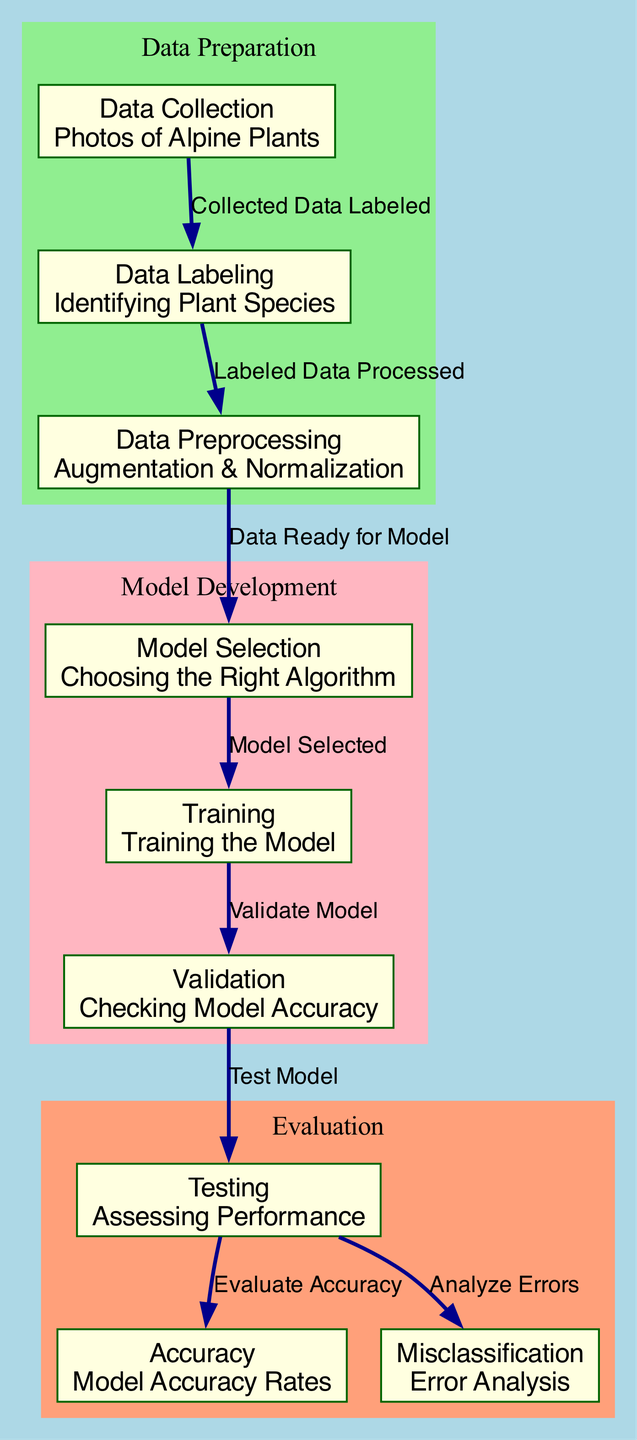What is the first step in this machine learning process? The first step is "Data Collection," which involves gathering photos of alpine plants. This is represented as the initial node in the diagram.
Answer: Data Collection What is the output of the "Testing" node? The "Testing" node leads to two outputs: "Accuracy" and "Misclassification," indicating that the model is evaluated for both performance metrics.
Answer: Accuracy and Misclassification How many main stages are depicted in the diagram? There are three main stages in the diagram: Data Preparation, Model Development, and Evaluation, each represented by clustered nodes.
Answer: Three What occurs immediately after "Data Labeling"? After "Data Labeling," the next step is "Data Preprocessing," indicating that the labeled data is processed for use in model selection.
Answer: Data Preprocessing Which node directly evaluates the model's performance? The node "Testing" directly evaluates the model's performance, as it assesses the outcomes based on the training and validation phases.
Answer: Testing What does the "Training" node connect to next? The "Training" node connects next to the "Validation" node, indicating that the model undergoes validation after training is complete.
Answer: Validation What type of analysis is performed at the "Misclassification" node? The "Misclassification" node focuses on error analysis, which examines incorrect classifications made by the model.
Answer: Error Analysis Which node comes before "Model Selection"? "Data Preprocessing" comes directly before "Model Selection," indicating that data needs to be prepared before selecting a model.
Answer: Data Preprocessing What does the "Accuracy" node measure? The "Accuracy" node measures the model accuracy rates, reflecting how well the model is performing compared to the true classifications.
Answer: Model Accuracy Rates 